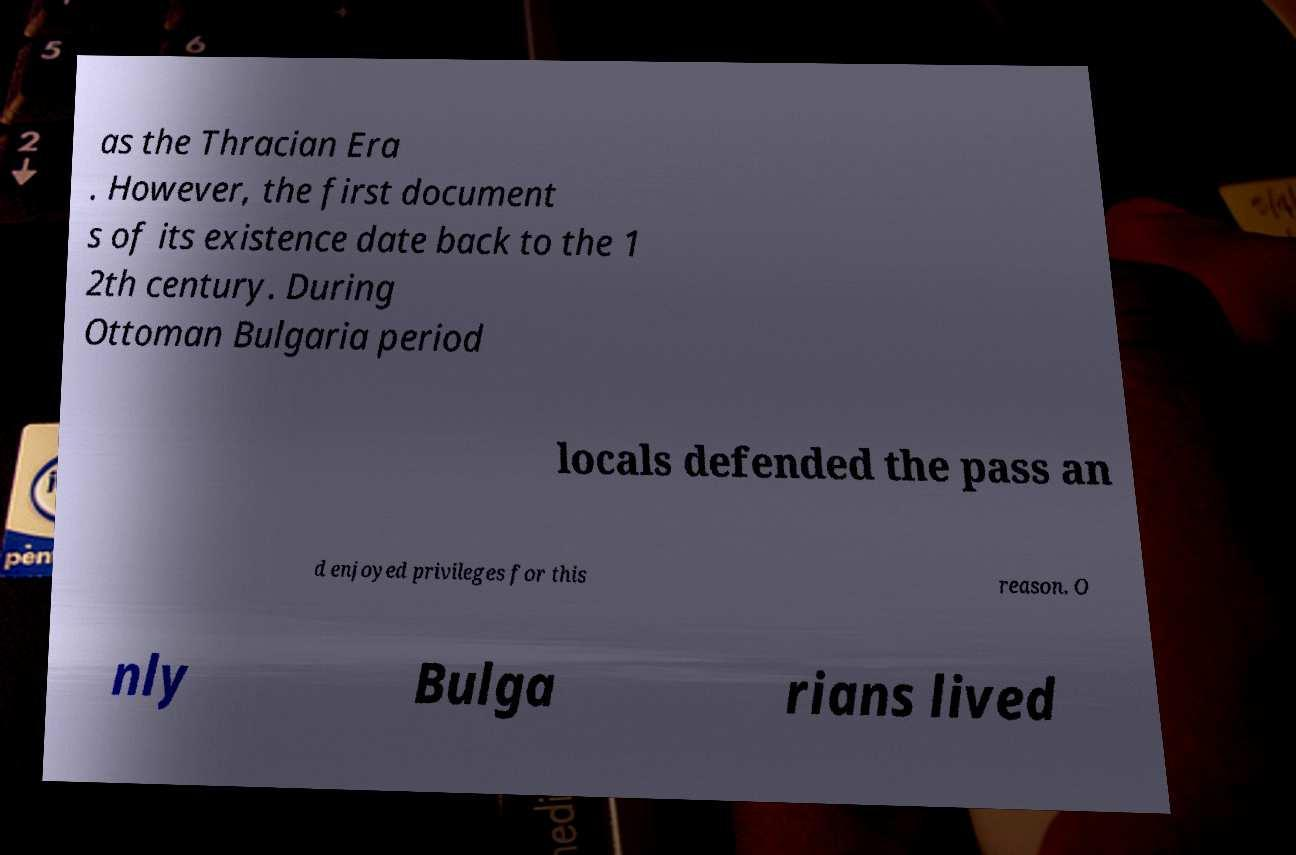Please read and relay the text visible in this image. What does it say? as the Thracian Era . However, the first document s of its existence date back to the 1 2th century. During Ottoman Bulgaria period locals defended the pass an d enjoyed privileges for this reason. O nly Bulga rians lived 